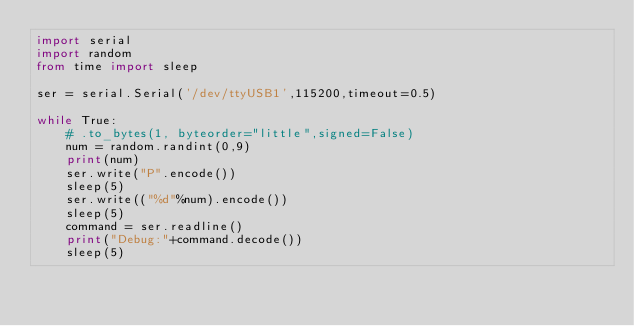Convert code to text. <code><loc_0><loc_0><loc_500><loc_500><_Python_>import serial
import random
from time import sleep

ser = serial.Serial('/dev/ttyUSB1',115200,timeout=0.5)

while True:
    # .to_bytes(1, byteorder="little",signed=False)
    num = random.randint(0,9)
    print(num)
    ser.write("P".encode())
    sleep(5)
    ser.write(("%d"%num).encode())
    sleep(5)
    command = ser.readline()
    print("Debug:"+command.decode())
    sleep(5)</code> 